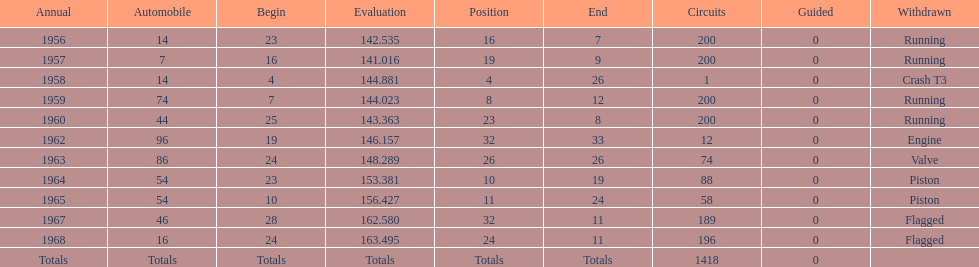What year did he have the same number car as 1964? 1965. 